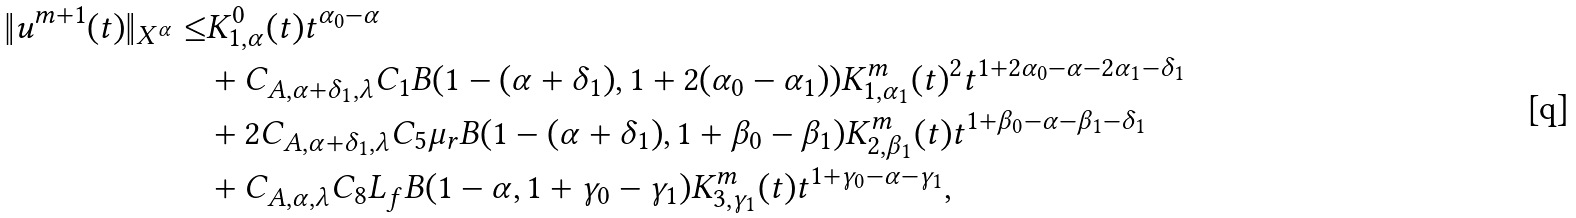<formula> <loc_0><loc_0><loc_500><loc_500>\| u ^ { m + 1 } ( t ) \| _ { X ^ { \alpha } } \leq & K ^ { 0 } _ { 1 , \alpha } ( t ) t ^ { \alpha _ { 0 } - \alpha } \\ & + C _ { A , \alpha + \delta _ { 1 } , \lambda } C _ { 1 } B ( 1 - ( \alpha + \delta _ { 1 } ) , 1 + 2 ( \alpha _ { 0 } - \alpha _ { 1 } ) ) K ^ { m } _ { 1 , \alpha _ { 1 } } ( t ) ^ { 2 } t ^ { 1 + 2 \alpha _ { 0 } - \alpha - 2 \alpha _ { 1 } - \delta _ { 1 } } \\ & + 2 C _ { A , \alpha + \delta _ { 1 } , \lambda } C _ { 5 } \mu _ { r } B ( 1 - ( \alpha + \delta _ { 1 } ) , 1 + \beta _ { 0 } - \beta _ { 1 } ) K ^ { m } _ { 2 , \beta _ { 1 } } ( t ) t ^ { 1 + \beta _ { 0 } - \alpha - \beta _ { 1 } - \delta _ { 1 } } \\ & + C _ { A , \alpha , \lambda } C _ { 8 } L _ { f } B ( 1 - \alpha , 1 + \gamma _ { 0 } - \gamma _ { 1 } ) K ^ { m } _ { 3 , \gamma _ { 1 } } ( t ) t ^ { 1 + \gamma _ { 0 } - \alpha - \gamma _ { 1 } } ,</formula> 